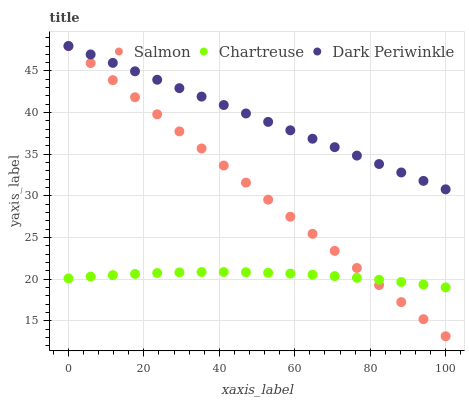Does Chartreuse have the minimum area under the curve?
Answer yes or no. Yes. Does Dark Periwinkle have the maximum area under the curve?
Answer yes or no. Yes. Does Salmon have the minimum area under the curve?
Answer yes or no. No. Does Salmon have the maximum area under the curve?
Answer yes or no. No. Is Salmon the smoothest?
Answer yes or no. Yes. Is Chartreuse the roughest?
Answer yes or no. Yes. Is Dark Periwinkle the smoothest?
Answer yes or no. No. Is Dark Periwinkle the roughest?
Answer yes or no. No. Does Salmon have the lowest value?
Answer yes or no. Yes. Does Dark Periwinkle have the lowest value?
Answer yes or no. No. Does Dark Periwinkle have the highest value?
Answer yes or no. Yes. Is Chartreuse less than Dark Periwinkle?
Answer yes or no. Yes. Is Dark Periwinkle greater than Chartreuse?
Answer yes or no. Yes. Does Salmon intersect Dark Periwinkle?
Answer yes or no. Yes. Is Salmon less than Dark Periwinkle?
Answer yes or no. No. Is Salmon greater than Dark Periwinkle?
Answer yes or no. No. Does Chartreuse intersect Dark Periwinkle?
Answer yes or no. No. 